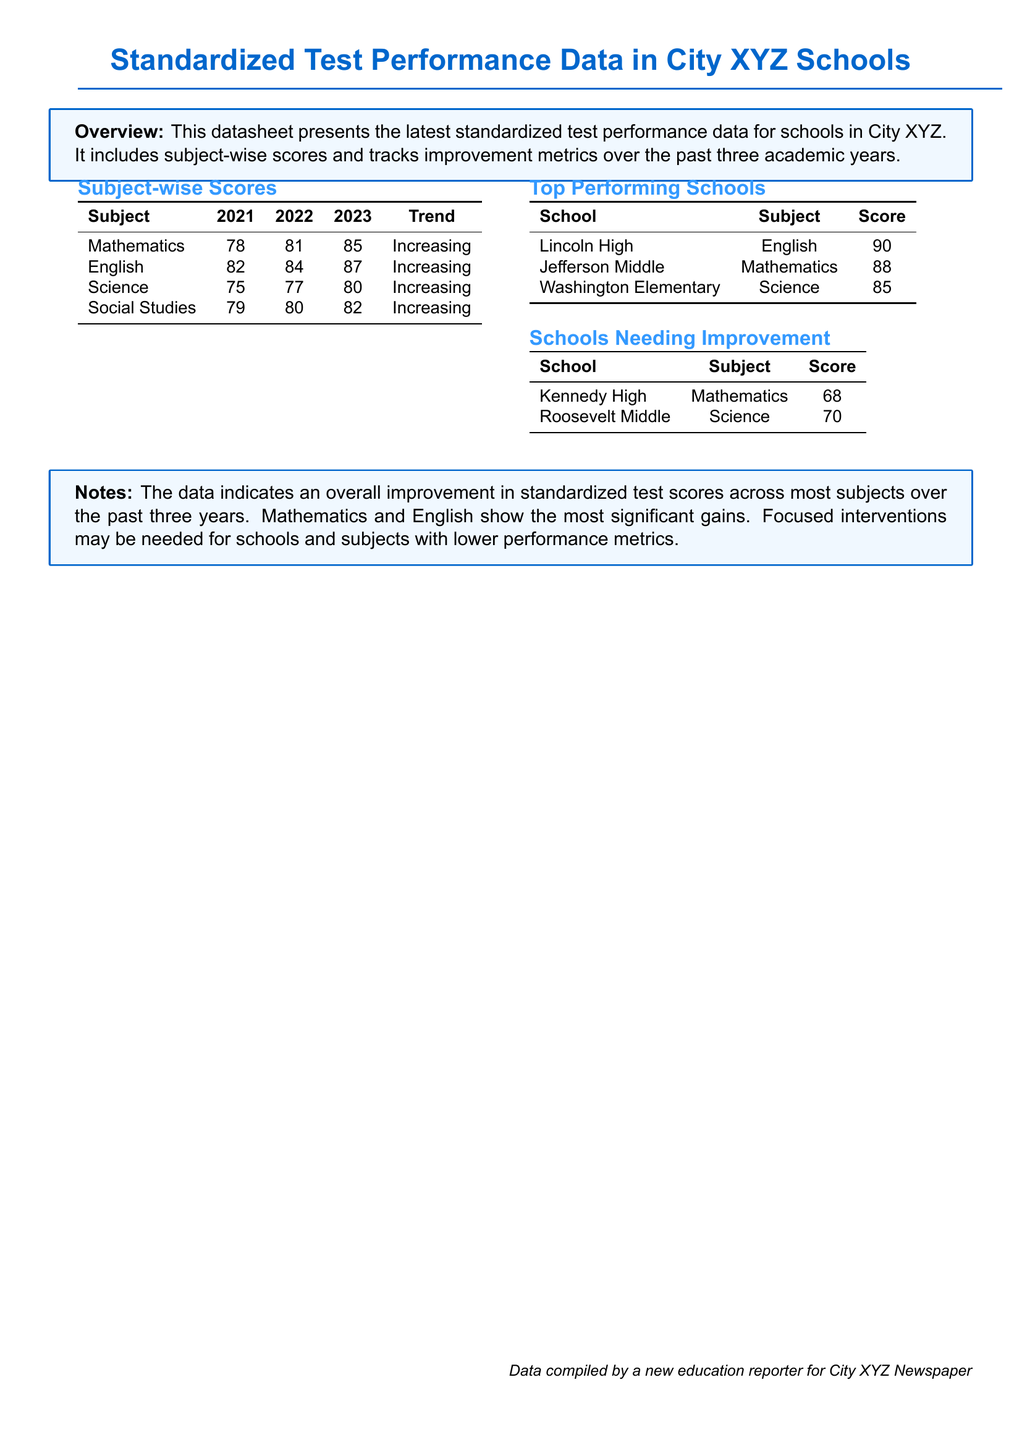What is the standardized test score for Mathematics in 2023? The score for Mathematics in 2023 is listed in the subject-wise scores table.
Answer: 85 Which school had the highest score in English? The table of top performing schools indicates that Lincoln High had the highest score in English.
Answer: Lincoln High What is the trend for Science scores from 2021 to 2023? The trend for Science scores is stated in the subject-wise scores section.
Answer: Increasing Which school needs improvement in Mathematics? The schools needing improvement can be found in the respective table.
Answer: Kennedy High What was the score for English in 2022? The score for English in 2022 is part of the subject-wise scores table.
Answer: 84 How many subjects showed an increasing trend over the years? The overview mentions trends across four subjects in the document.
Answer: Four What is the score for Roosevelt Middle in Science? The score for Roosevelt Middle in Science is noted in the schools needing improvement table.
Answer: 70 Which subject showed the most significant gains? The notes section provides insights on subjects with significant gains in scores.
Answer: Mathematics and English 